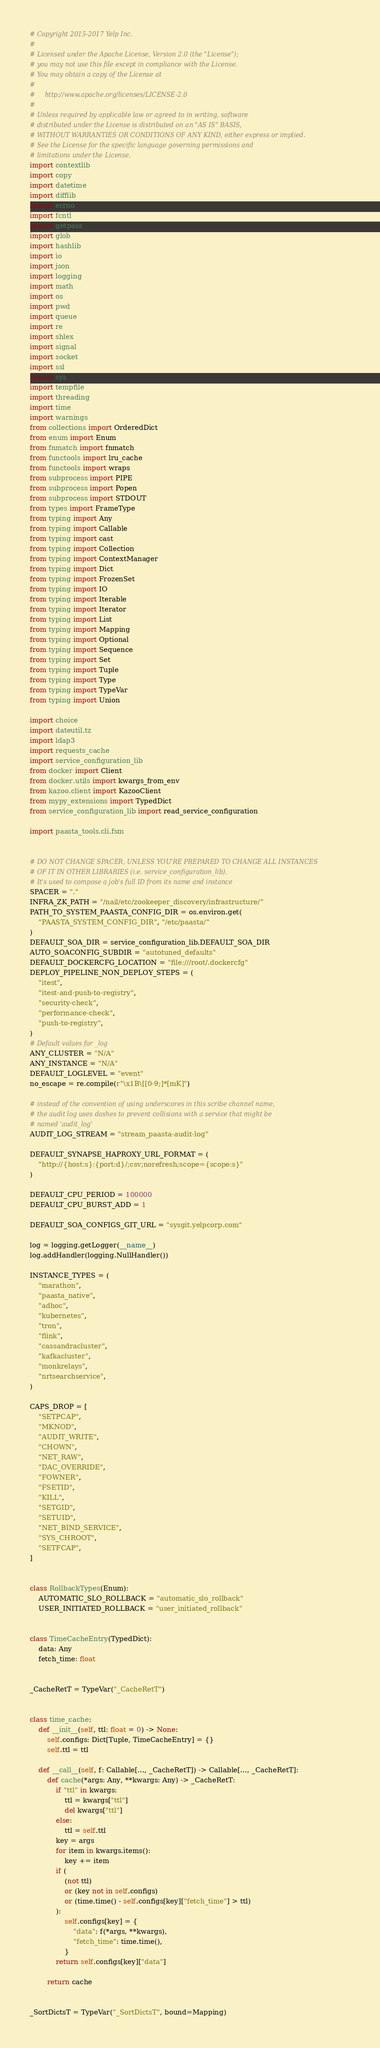<code> <loc_0><loc_0><loc_500><loc_500><_Python_># Copyright 2015-2017 Yelp Inc.
#
# Licensed under the Apache License, Version 2.0 (the "License");
# you may not use this file except in compliance with the License.
# You may obtain a copy of the License at
#
#     http://www.apache.org/licenses/LICENSE-2.0
#
# Unless required by applicable law or agreed to in writing, software
# distributed under the License is distributed on an "AS IS" BASIS,
# WITHOUT WARRANTIES OR CONDITIONS OF ANY KIND, either express or implied.
# See the License for the specific language governing permissions and
# limitations under the License.
import contextlib
import copy
import datetime
import difflib
import errno
import fcntl
import getpass
import glob
import hashlib
import io
import json
import logging
import math
import os
import pwd
import queue
import re
import shlex
import signal
import socket
import ssl
import sys
import tempfile
import threading
import time
import warnings
from collections import OrderedDict
from enum import Enum
from fnmatch import fnmatch
from functools import lru_cache
from functools import wraps
from subprocess import PIPE
from subprocess import Popen
from subprocess import STDOUT
from types import FrameType
from typing import Any
from typing import Callable
from typing import cast
from typing import Collection
from typing import ContextManager
from typing import Dict
from typing import FrozenSet
from typing import IO
from typing import Iterable
from typing import Iterator
from typing import List
from typing import Mapping
from typing import Optional
from typing import Sequence
from typing import Set
from typing import Tuple
from typing import Type
from typing import TypeVar
from typing import Union

import choice
import dateutil.tz
import ldap3
import requests_cache
import service_configuration_lib
from docker import Client
from docker.utils import kwargs_from_env
from kazoo.client import KazooClient
from mypy_extensions import TypedDict
from service_configuration_lib import read_service_configuration

import paasta_tools.cli.fsm


# DO NOT CHANGE SPACER, UNLESS YOU'RE PREPARED TO CHANGE ALL INSTANCES
# OF IT IN OTHER LIBRARIES (i.e. service_configuration_lib).
# It's used to compose a job's full ID from its name and instance
SPACER = "."
INFRA_ZK_PATH = "/nail/etc/zookeeper_discovery/infrastructure/"
PATH_TO_SYSTEM_PAASTA_CONFIG_DIR = os.environ.get(
    "PAASTA_SYSTEM_CONFIG_DIR", "/etc/paasta/"
)
DEFAULT_SOA_DIR = service_configuration_lib.DEFAULT_SOA_DIR
AUTO_SOACONFIG_SUBDIR = "autotuned_defaults"
DEFAULT_DOCKERCFG_LOCATION = "file:///root/.dockercfg"
DEPLOY_PIPELINE_NON_DEPLOY_STEPS = (
    "itest",
    "itest-and-push-to-registry",
    "security-check",
    "performance-check",
    "push-to-registry",
)
# Default values for _log
ANY_CLUSTER = "N/A"
ANY_INSTANCE = "N/A"
DEFAULT_LOGLEVEL = "event"
no_escape = re.compile(r"\x1B\[[0-9;]*[mK]")

# instead of the convention of using underscores in this scribe channel name,
# the audit log uses dashes to prevent collisions with a service that might be
# named 'audit_log'
AUDIT_LOG_STREAM = "stream_paasta-audit-log"

DEFAULT_SYNAPSE_HAPROXY_URL_FORMAT = (
    "http://{host:s}:{port:d}/;csv;norefresh;scope={scope:s}"
)

DEFAULT_CPU_PERIOD = 100000
DEFAULT_CPU_BURST_ADD = 1

DEFAULT_SOA_CONFIGS_GIT_URL = "sysgit.yelpcorp.com"

log = logging.getLogger(__name__)
log.addHandler(logging.NullHandler())

INSTANCE_TYPES = (
    "marathon",
    "paasta_native",
    "adhoc",
    "kubernetes",
    "tron",
    "flink",
    "cassandracluster",
    "kafkacluster",
    "monkrelays",
    "nrtsearchservice",
)

CAPS_DROP = [
    "SETPCAP",
    "MKNOD",
    "AUDIT_WRITE",
    "CHOWN",
    "NET_RAW",
    "DAC_OVERRIDE",
    "FOWNER",
    "FSETID",
    "KILL",
    "SETGID",
    "SETUID",
    "NET_BIND_SERVICE",
    "SYS_CHROOT",
    "SETFCAP",
]


class RollbackTypes(Enum):
    AUTOMATIC_SLO_ROLLBACK = "automatic_slo_rollback"
    USER_INITIATED_ROLLBACK = "user_initiated_rollback"


class TimeCacheEntry(TypedDict):
    data: Any
    fetch_time: float


_CacheRetT = TypeVar("_CacheRetT")


class time_cache:
    def __init__(self, ttl: float = 0) -> None:
        self.configs: Dict[Tuple, TimeCacheEntry] = {}
        self.ttl = ttl

    def __call__(self, f: Callable[..., _CacheRetT]) -> Callable[..., _CacheRetT]:
        def cache(*args: Any, **kwargs: Any) -> _CacheRetT:
            if "ttl" in kwargs:
                ttl = kwargs["ttl"]
                del kwargs["ttl"]
            else:
                ttl = self.ttl
            key = args
            for item in kwargs.items():
                key += item
            if (
                (not ttl)
                or (key not in self.configs)
                or (time.time() - self.configs[key]["fetch_time"] > ttl)
            ):
                self.configs[key] = {
                    "data": f(*args, **kwargs),
                    "fetch_time": time.time(),
                }
            return self.configs[key]["data"]

        return cache


_SortDictsT = TypeVar("_SortDictsT", bound=Mapping)

</code> 